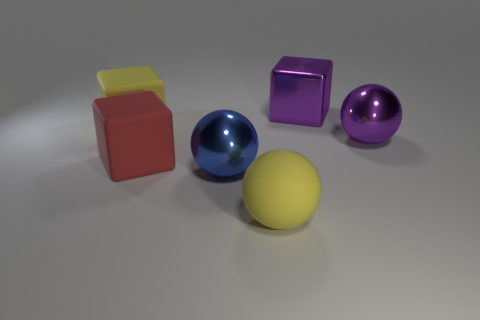Subtract all large blue balls. How many balls are left? 2 Add 4 large red blocks. How many objects exist? 10 Subtract all purple balls. How many balls are left? 2 Subtract all brown spheres. Subtract all blue cylinders. How many spheres are left? 3 Subtract 1 red blocks. How many objects are left? 5 Subtract 1 spheres. How many spheres are left? 2 Subtract all small matte cylinders. Subtract all large blue balls. How many objects are left? 5 Add 2 big purple metallic cubes. How many big purple metallic cubes are left? 3 Add 4 big yellow rubber balls. How many big yellow rubber balls exist? 5 